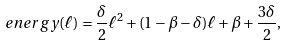<formula> <loc_0><loc_0><loc_500><loc_500>\ e n e r g y ( \ell ) = \frac { \delta } { 2 } \ell ^ { 2 } + ( 1 - \beta - \delta ) \ell + \beta + \frac { 3 \delta } { 2 } ,</formula> 